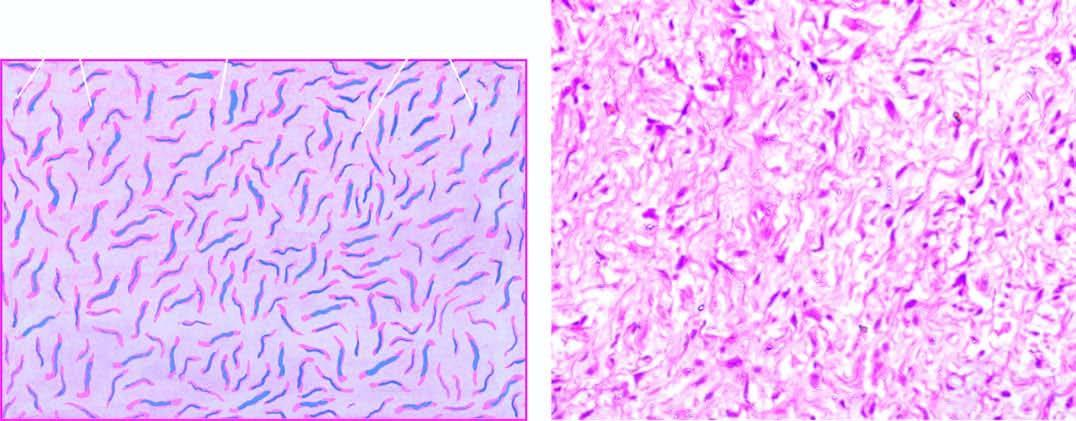s broad base also identified?
Answer the question using a single word or phrase. No 